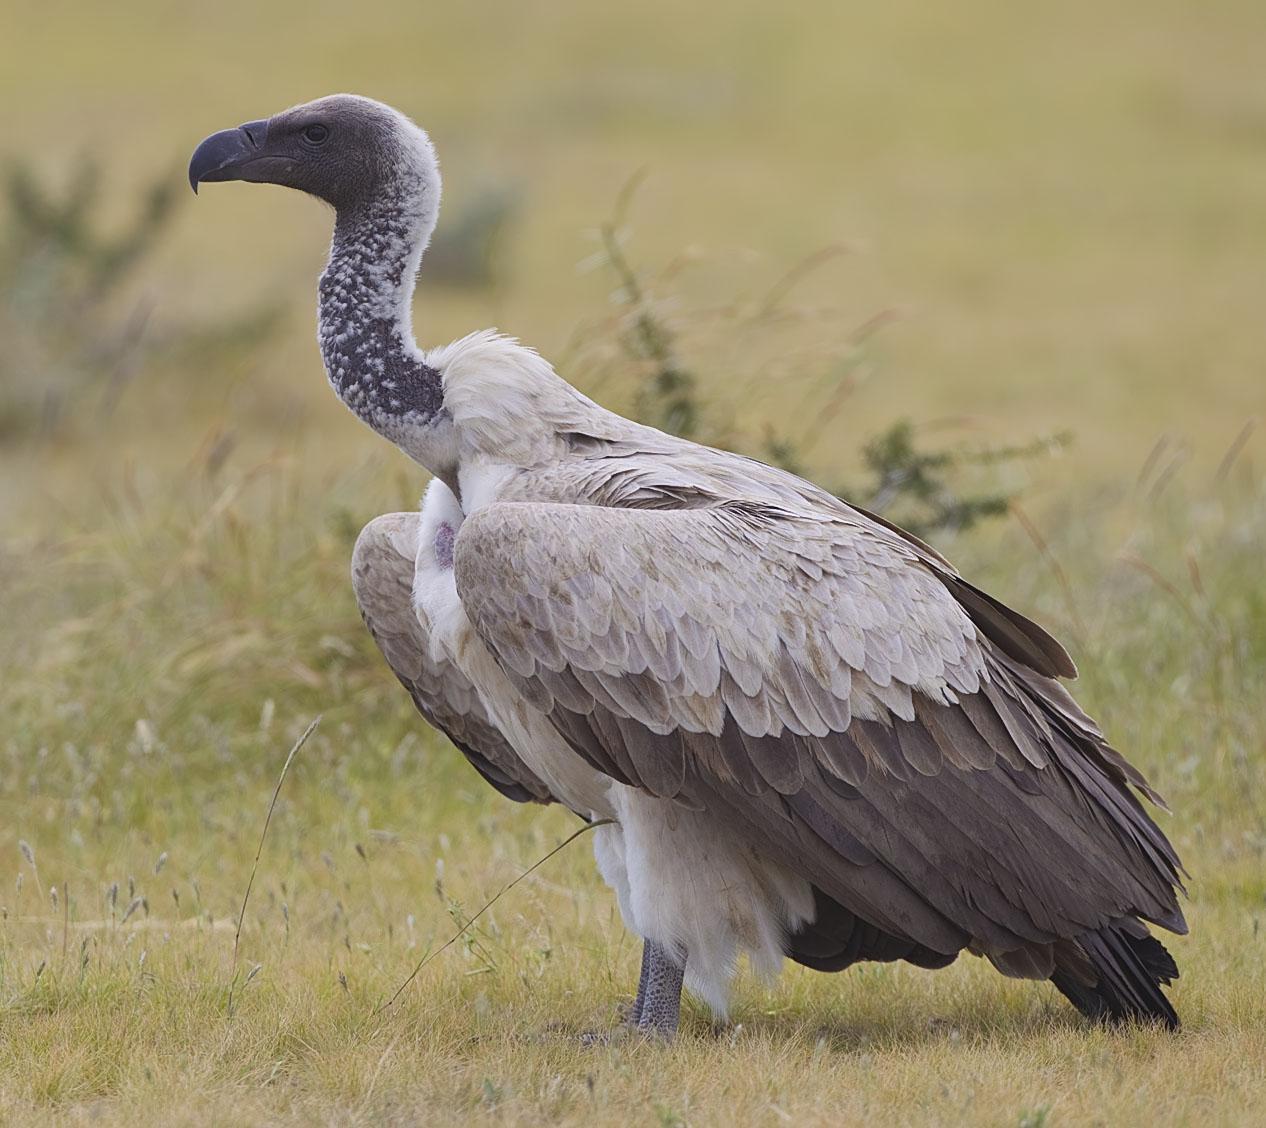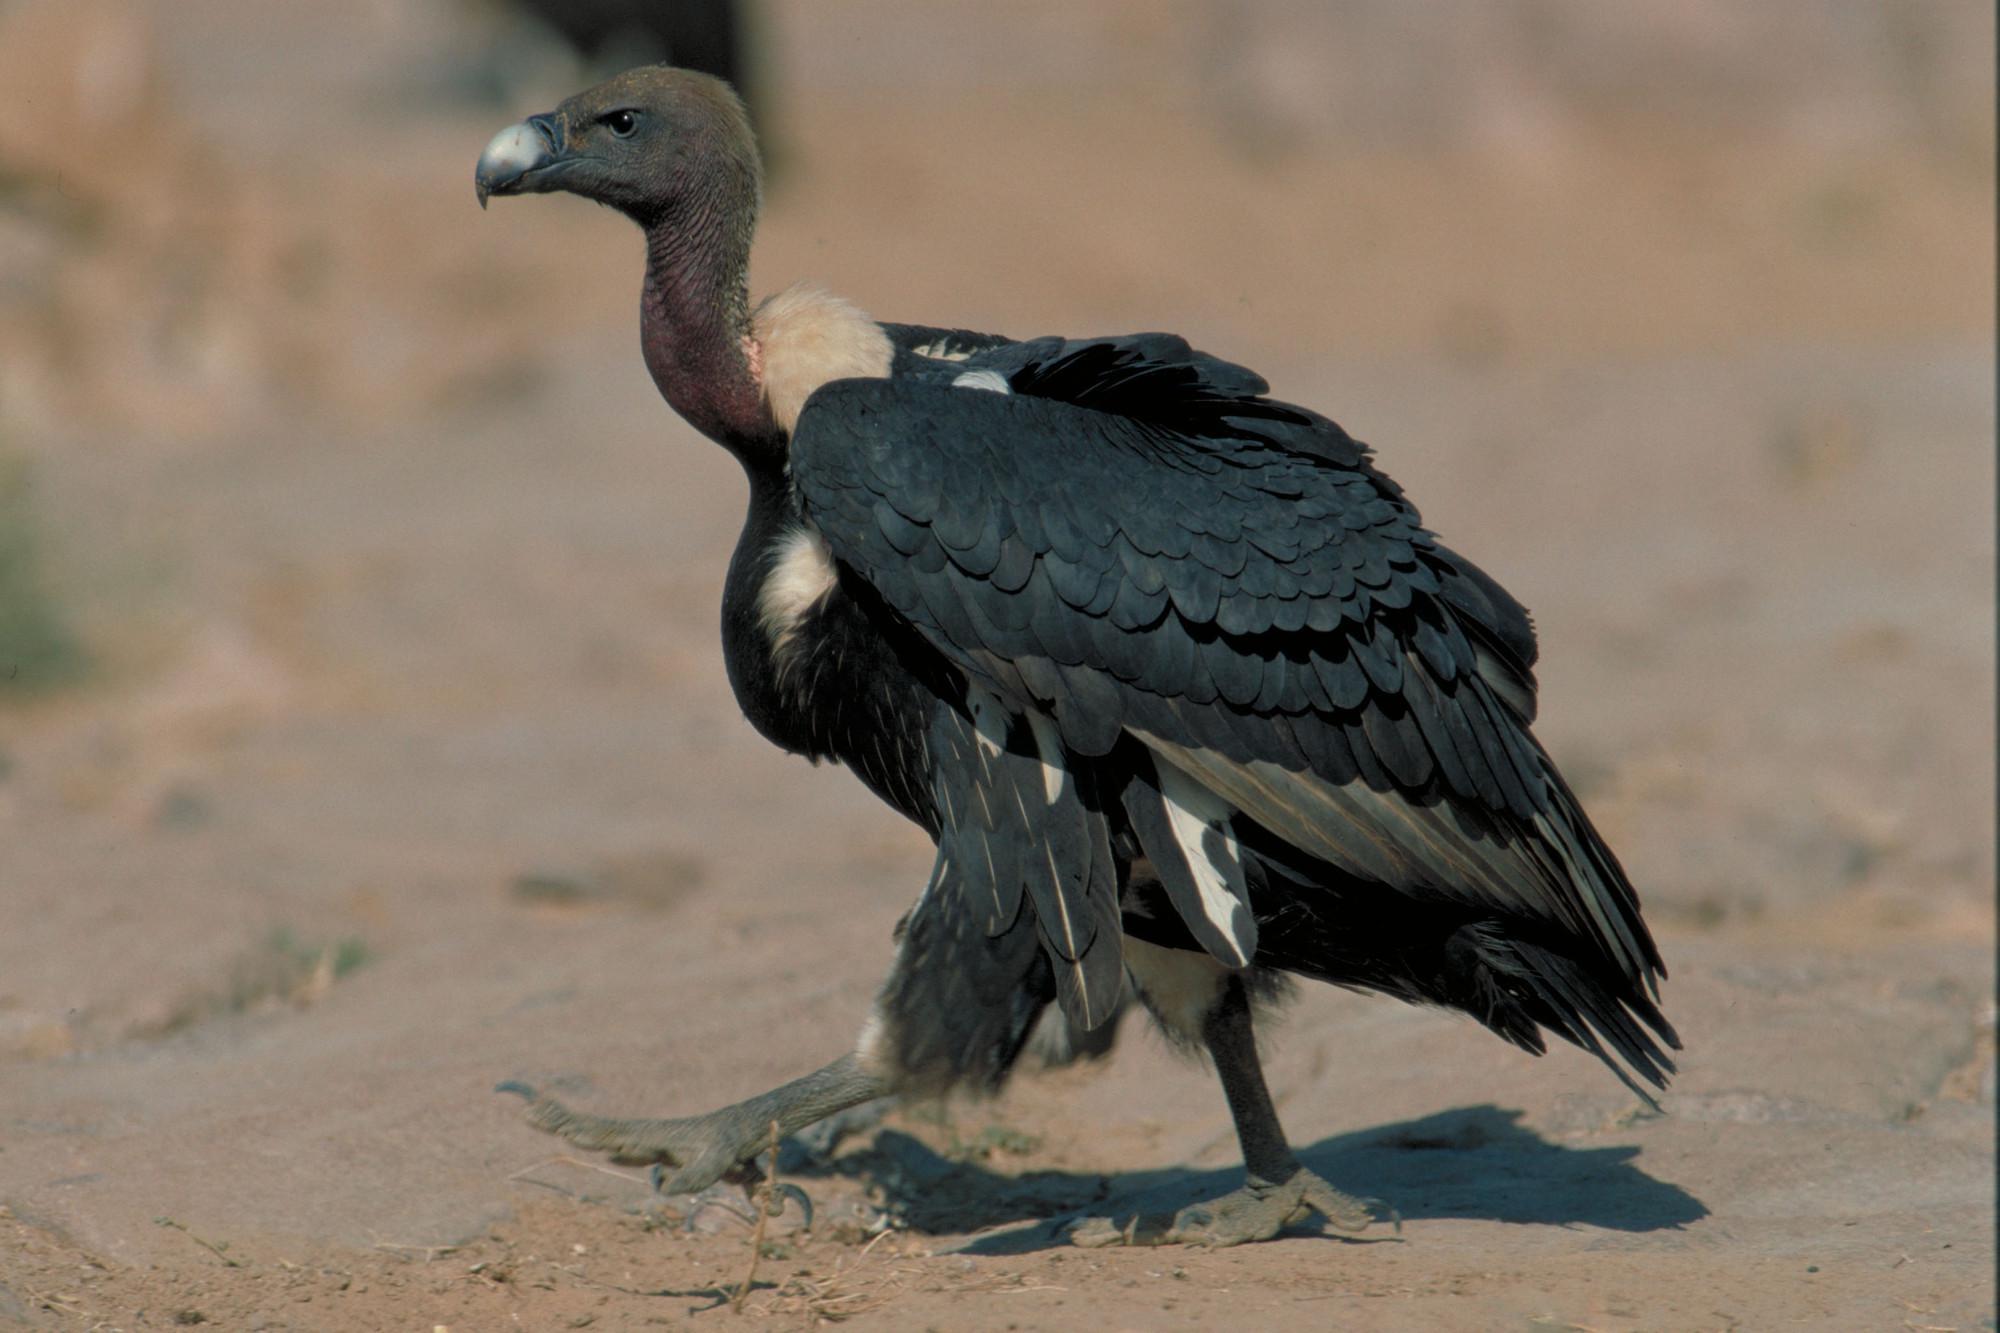The first image is the image on the left, the second image is the image on the right. Considering the images on both sides, is "In the pair, one bird is standing on a post and the other on a flat surface." valid? Answer yes or no. No. 